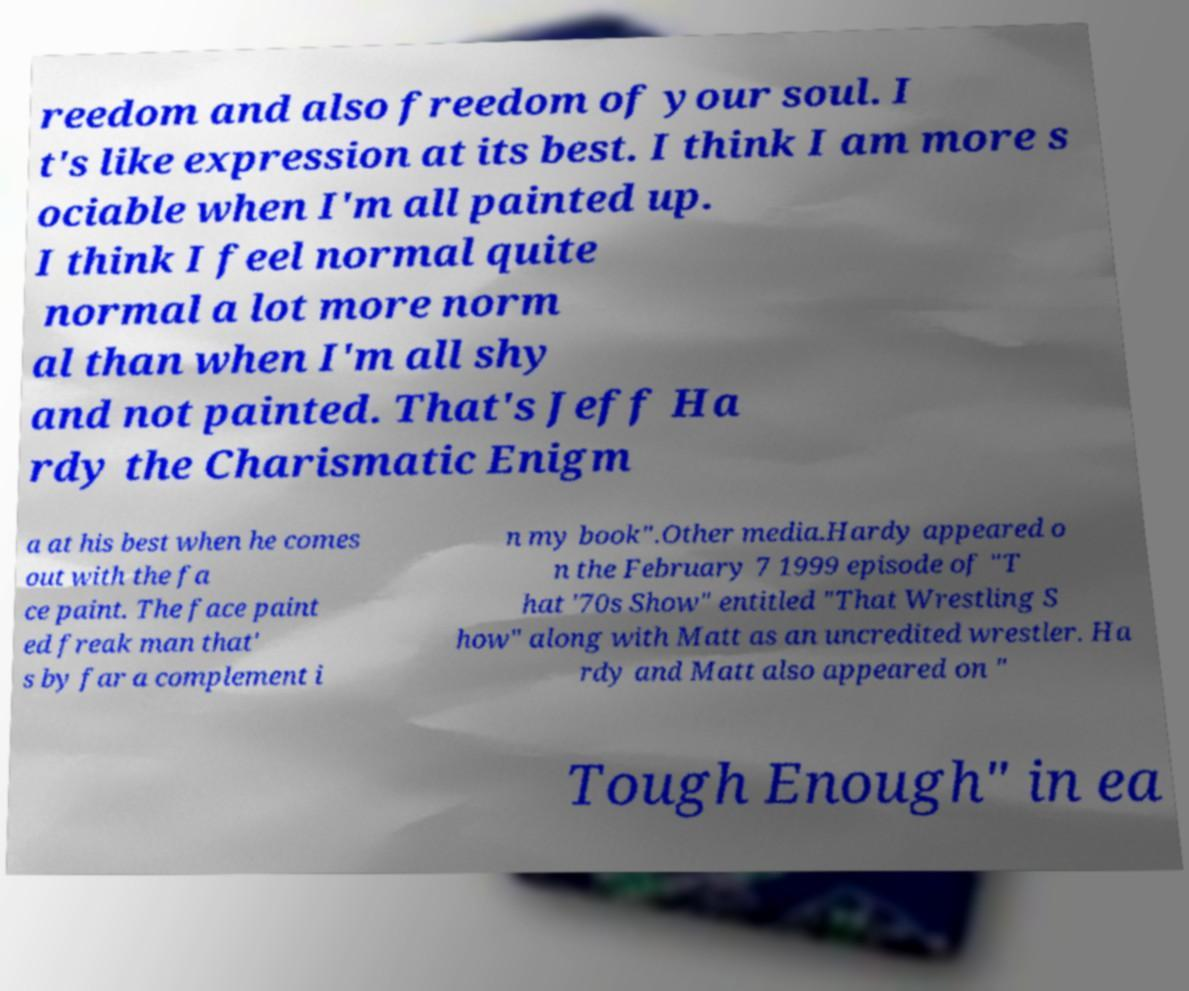Please identify and transcribe the text found in this image. reedom and also freedom of your soul. I t's like expression at its best. I think I am more s ociable when I'm all painted up. I think I feel normal quite normal a lot more norm al than when I'm all shy and not painted. That's Jeff Ha rdy the Charismatic Enigm a at his best when he comes out with the fa ce paint. The face paint ed freak man that' s by far a complement i n my book".Other media.Hardy appeared o n the February 7 1999 episode of "T hat '70s Show" entitled "That Wrestling S how" along with Matt as an uncredited wrestler. Ha rdy and Matt also appeared on " Tough Enough" in ea 